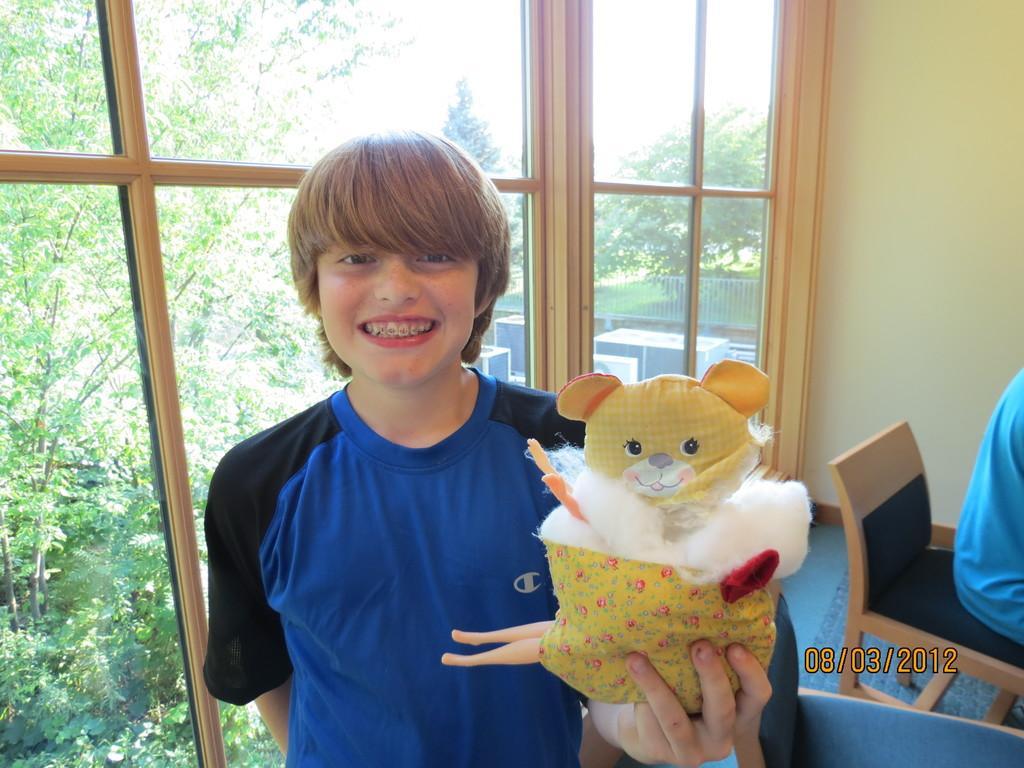Could you give a brief overview of what you see in this image? In this image there is a boy who is wearing a blue t-shirt and he is holding a toy. On the right there is a person who is sitting on a chair. On the left there is a window through which we can see a tree and a sky. 